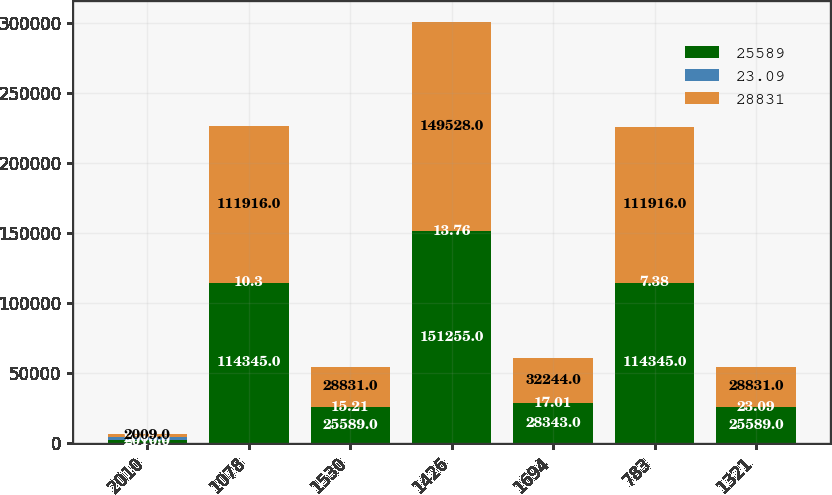Convert chart to OTSL. <chart><loc_0><loc_0><loc_500><loc_500><stacked_bar_chart><ecel><fcel>2010<fcel>1078<fcel>1530<fcel>1426<fcel>1694<fcel>783<fcel>1321<nl><fcel>25589<fcel>2010<fcel>114345<fcel>25589<fcel>151255<fcel>28343<fcel>114345<fcel>25589<nl><fcel>23.09<fcel>2009<fcel>10.3<fcel>15.21<fcel>13.76<fcel>17.01<fcel>7.38<fcel>23.09<nl><fcel>28831<fcel>2009<fcel>111916<fcel>28831<fcel>149528<fcel>32244<fcel>111916<fcel>28831<nl></chart> 